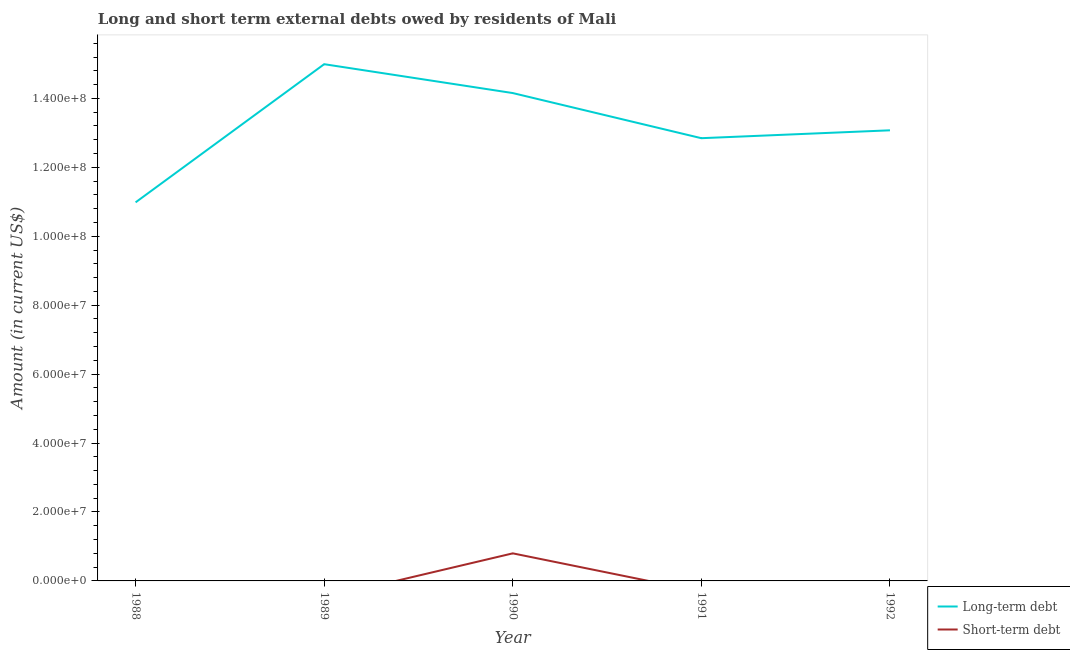How many different coloured lines are there?
Give a very brief answer. 2. Across all years, what is the maximum short-term debts owed by residents?
Make the answer very short. 8.00e+06. Across all years, what is the minimum long-term debts owed by residents?
Make the answer very short. 1.10e+08. In which year was the short-term debts owed by residents maximum?
Make the answer very short. 1990. What is the total long-term debts owed by residents in the graph?
Provide a succinct answer. 6.61e+08. What is the difference between the long-term debts owed by residents in 1989 and that in 1990?
Your answer should be very brief. 8.38e+06. What is the difference between the short-term debts owed by residents in 1991 and the long-term debts owed by residents in 1992?
Offer a terse response. -1.31e+08. What is the average long-term debts owed by residents per year?
Provide a succinct answer. 1.32e+08. In the year 1990, what is the difference between the long-term debts owed by residents and short-term debts owed by residents?
Ensure brevity in your answer.  1.34e+08. What is the ratio of the long-term debts owed by residents in 1988 to that in 1990?
Offer a very short reply. 0.78. Is the long-term debts owed by residents in 1989 less than that in 1990?
Provide a succinct answer. No. What is the difference between the highest and the second highest long-term debts owed by residents?
Make the answer very short. 8.38e+06. What is the difference between the highest and the lowest long-term debts owed by residents?
Your answer should be very brief. 4.01e+07. In how many years, is the short-term debts owed by residents greater than the average short-term debts owed by residents taken over all years?
Provide a short and direct response. 1. Is the sum of the long-term debts owed by residents in 1989 and 1991 greater than the maximum short-term debts owed by residents across all years?
Your answer should be compact. Yes. Does the long-term debts owed by residents monotonically increase over the years?
Give a very brief answer. No. Is the short-term debts owed by residents strictly greater than the long-term debts owed by residents over the years?
Make the answer very short. No. Is the long-term debts owed by residents strictly less than the short-term debts owed by residents over the years?
Keep it short and to the point. No. How many lines are there?
Offer a very short reply. 2. How many years are there in the graph?
Offer a very short reply. 5. What is the difference between two consecutive major ticks on the Y-axis?
Offer a terse response. 2.00e+07. Does the graph contain any zero values?
Give a very brief answer. Yes. Does the graph contain grids?
Your answer should be compact. No. Where does the legend appear in the graph?
Make the answer very short. Bottom right. How many legend labels are there?
Your answer should be very brief. 2. How are the legend labels stacked?
Ensure brevity in your answer.  Vertical. What is the title of the graph?
Make the answer very short. Long and short term external debts owed by residents of Mali. Does "Number of departures" appear as one of the legend labels in the graph?
Offer a very short reply. No. What is the label or title of the Y-axis?
Your answer should be very brief. Amount (in current US$). What is the Amount (in current US$) in Long-term debt in 1988?
Your answer should be compact. 1.10e+08. What is the Amount (in current US$) in Long-term debt in 1989?
Offer a terse response. 1.50e+08. What is the Amount (in current US$) in Short-term debt in 1989?
Ensure brevity in your answer.  0. What is the Amount (in current US$) in Long-term debt in 1990?
Your answer should be compact. 1.42e+08. What is the Amount (in current US$) in Long-term debt in 1991?
Your answer should be compact. 1.28e+08. What is the Amount (in current US$) of Long-term debt in 1992?
Ensure brevity in your answer.  1.31e+08. Across all years, what is the maximum Amount (in current US$) of Long-term debt?
Keep it short and to the point. 1.50e+08. Across all years, what is the minimum Amount (in current US$) of Long-term debt?
Ensure brevity in your answer.  1.10e+08. Across all years, what is the minimum Amount (in current US$) in Short-term debt?
Provide a short and direct response. 0. What is the total Amount (in current US$) of Long-term debt in the graph?
Keep it short and to the point. 6.61e+08. What is the total Amount (in current US$) of Short-term debt in the graph?
Make the answer very short. 8.00e+06. What is the difference between the Amount (in current US$) of Long-term debt in 1988 and that in 1989?
Your answer should be compact. -4.01e+07. What is the difference between the Amount (in current US$) in Long-term debt in 1988 and that in 1990?
Provide a succinct answer. -3.17e+07. What is the difference between the Amount (in current US$) of Long-term debt in 1988 and that in 1991?
Provide a short and direct response. -1.86e+07. What is the difference between the Amount (in current US$) of Long-term debt in 1988 and that in 1992?
Make the answer very short. -2.09e+07. What is the difference between the Amount (in current US$) in Long-term debt in 1989 and that in 1990?
Provide a short and direct response. 8.38e+06. What is the difference between the Amount (in current US$) in Long-term debt in 1989 and that in 1991?
Keep it short and to the point. 2.15e+07. What is the difference between the Amount (in current US$) of Long-term debt in 1989 and that in 1992?
Offer a very short reply. 1.92e+07. What is the difference between the Amount (in current US$) of Long-term debt in 1990 and that in 1991?
Ensure brevity in your answer.  1.31e+07. What is the difference between the Amount (in current US$) in Long-term debt in 1990 and that in 1992?
Your response must be concise. 1.08e+07. What is the difference between the Amount (in current US$) of Long-term debt in 1991 and that in 1992?
Provide a succinct answer. -2.29e+06. What is the difference between the Amount (in current US$) of Long-term debt in 1988 and the Amount (in current US$) of Short-term debt in 1990?
Offer a very short reply. 1.02e+08. What is the difference between the Amount (in current US$) in Long-term debt in 1989 and the Amount (in current US$) in Short-term debt in 1990?
Make the answer very short. 1.42e+08. What is the average Amount (in current US$) of Long-term debt per year?
Your response must be concise. 1.32e+08. What is the average Amount (in current US$) of Short-term debt per year?
Make the answer very short. 1.60e+06. In the year 1990, what is the difference between the Amount (in current US$) of Long-term debt and Amount (in current US$) of Short-term debt?
Offer a very short reply. 1.34e+08. What is the ratio of the Amount (in current US$) of Long-term debt in 1988 to that in 1989?
Make the answer very short. 0.73. What is the ratio of the Amount (in current US$) in Long-term debt in 1988 to that in 1990?
Provide a succinct answer. 0.78. What is the ratio of the Amount (in current US$) in Long-term debt in 1988 to that in 1991?
Give a very brief answer. 0.86. What is the ratio of the Amount (in current US$) of Long-term debt in 1988 to that in 1992?
Ensure brevity in your answer.  0.84. What is the ratio of the Amount (in current US$) in Long-term debt in 1989 to that in 1990?
Provide a short and direct response. 1.06. What is the ratio of the Amount (in current US$) of Long-term debt in 1989 to that in 1991?
Keep it short and to the point. 1.17. What is the ratio of the Amount (in current US$) of Long-term debt in 1989 to that in 1992?
Provide a succinct answer. 1.15. What is the ratio of the Amount (in current US$) in Long-term debt in 1990 to that in 1991?
Offer a very short reply. 1.1. What is the ratio of the Amount (in current US$) of Long-term debt in 1990 to that in 1992?
Provide a short and direct response. 1.08. What is the ratio of the Amount (in current US$) in Long-term debt in 1991 to that in 1992?
Give a very brief answer. 0.98. What is the difference between the highest and the second highest Amount (in current US$) of Long-term debt?
Provide a succinct answer. 8.38e+06. What is the difference between the highest and the lowest Amount (in current US$) in Long-term debt?
Give a very brief answer. 4.01e+07. 